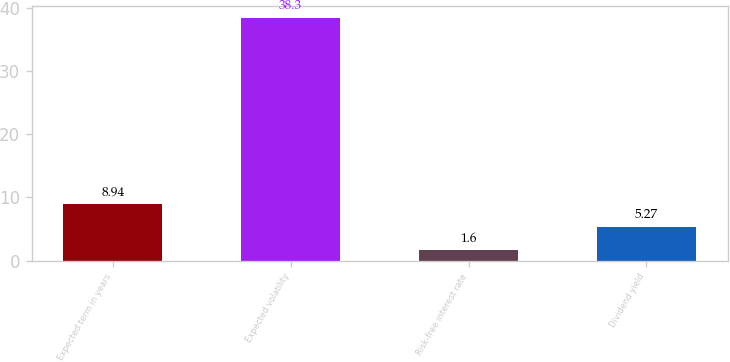Convert chart. <chart><loc_0><loc_0><loc_500><loc_500><bar_chart><fcel>Expected term in years<fcel>Expected volatility<fcel>Risk-free interest rate<fcel>Dividend yield<nl><fcel>8.94<fcel>38.3<fcel>1.6<fcel>5.27<nl></chart> 